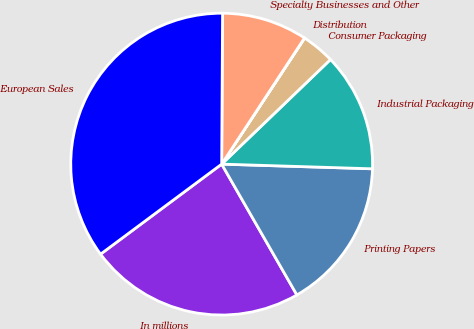Convert chart. <chart><loc_0><loc_0><loc_500><loc_500><pie_chart><fcel>In millions<fcel>Printing Papers<fcel>Industrial Packaging<fcel>Consumer Packaging<fcel>Distribution<fcel>Specialty Businesses and Other<fcel>European Sales<nl><fcel>23.13%<fcel>16.2%<fcel>12.68%<fcel>3.55%<fcel>0.02%<fcel>9.15%<fcel>35.27%<nl></chart> 